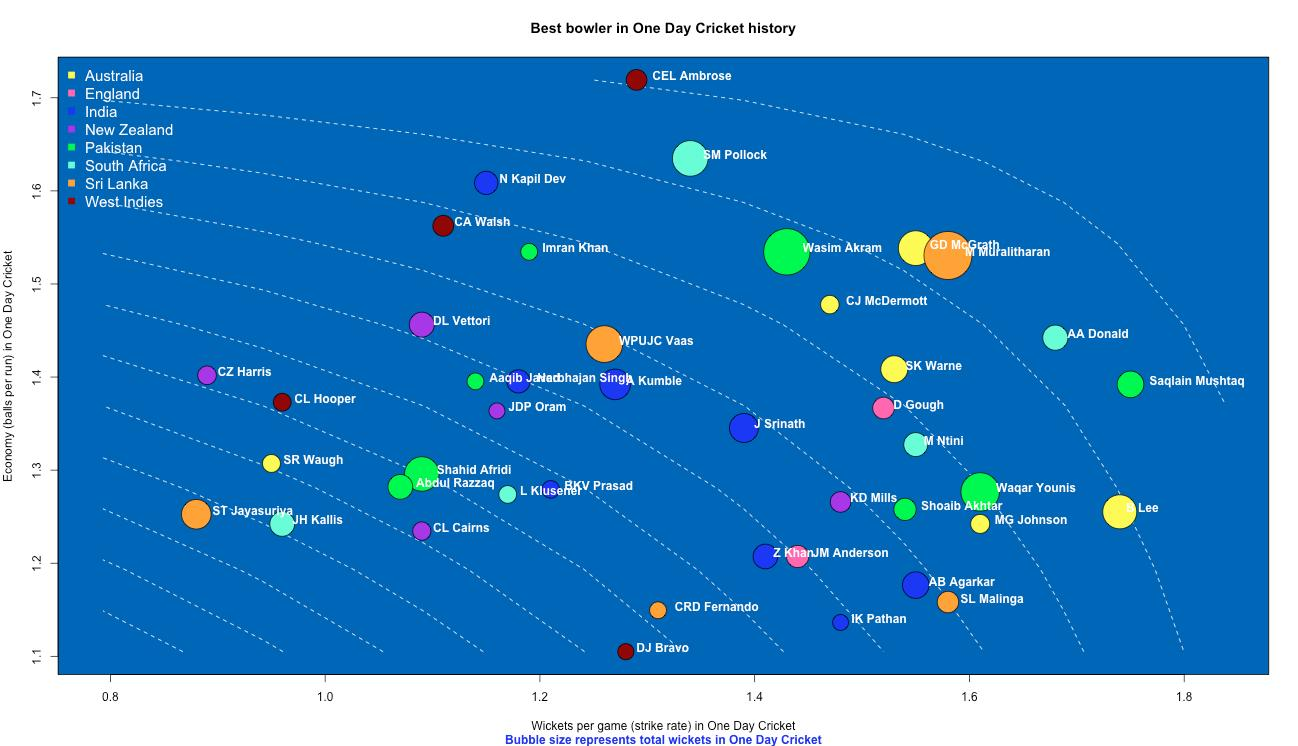Give some essential details in this illustration. M Muralitharan, a Sri Lankan bowler, holds the record for the highest number of wickets taken in one day cricket. The South African bowler with the highest strike rate in one-day cricket is AA Donald, with a remarkable average of delivering a wicket with every 9.5 balls faced. Ajit Kumble, the Indian bowler, holds the record for the most wickets taken in one day cricket with the highest number of wickets. Which Pakistan bowler has taken the highest number of wickets in one day cricket, making him a renowned player in the sport? It is none other than Wasim Akram, who has consistently impressed with his exceptional bowling skills. The Australian bowler with the highest strike rate in one-day cricket is Lee, who achieved this remarkable feat with his outstanding performance. 